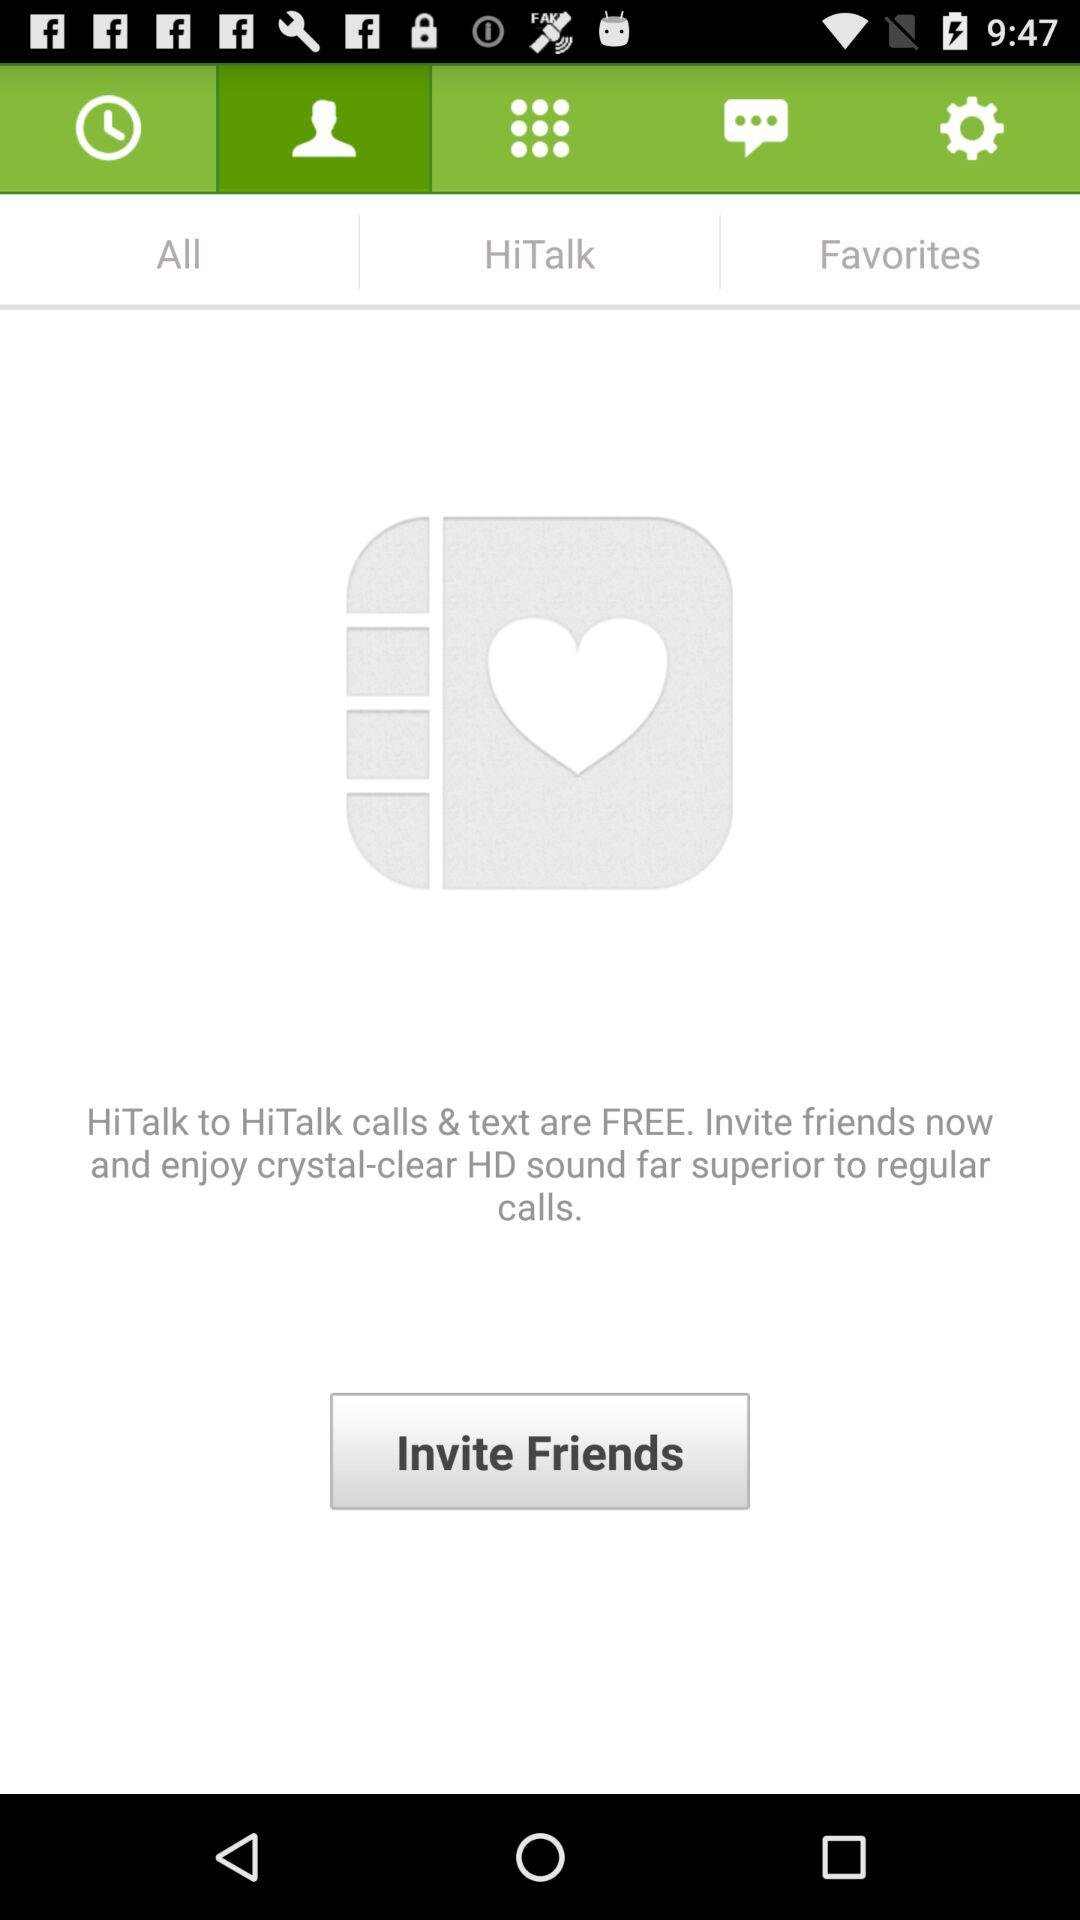Which tab has been selected? The selected tab is "Contacts". 